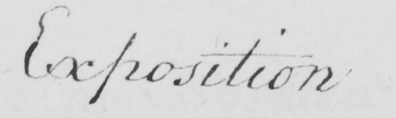Please transcribe the handwritten text in this image. Exposition 